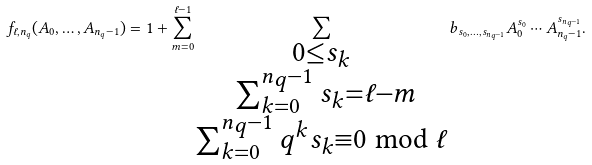<formula> <loc_0><loc_0><loc_500><loc_500>f _ { \ell , n _ { q } } ( A _ { 0 } , \dots , A _ { n _ { q } - 1 } ) = 1 + \sum _ { m = 0 } ^ { \ell - 1 } \sum _ { \substack { 0 \leq s _ { k } \\ \ \sum _ { k = 0 } ^ { n _ { q } - 1 } s _ { k } = \ell - m \\ \sum _ { k = 0 } ^ { n _ { q } - 1 } q ^ { k } s _ { k } \equiv 0 \bmod { \ell } } } b _ { s _ { 0 } , \dots , s _ { n _ { q } - 1 } } A _ { 0 } ^ { s _ { 0 } } \cdots A _ { n _ { q } - 1 } ^ { s _ { n _ { q } - 1 } } .</formula> 